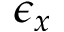<formula> <loc_0><loc_0><loc_500><loc_500>\epsilon _ { x }</formula> 